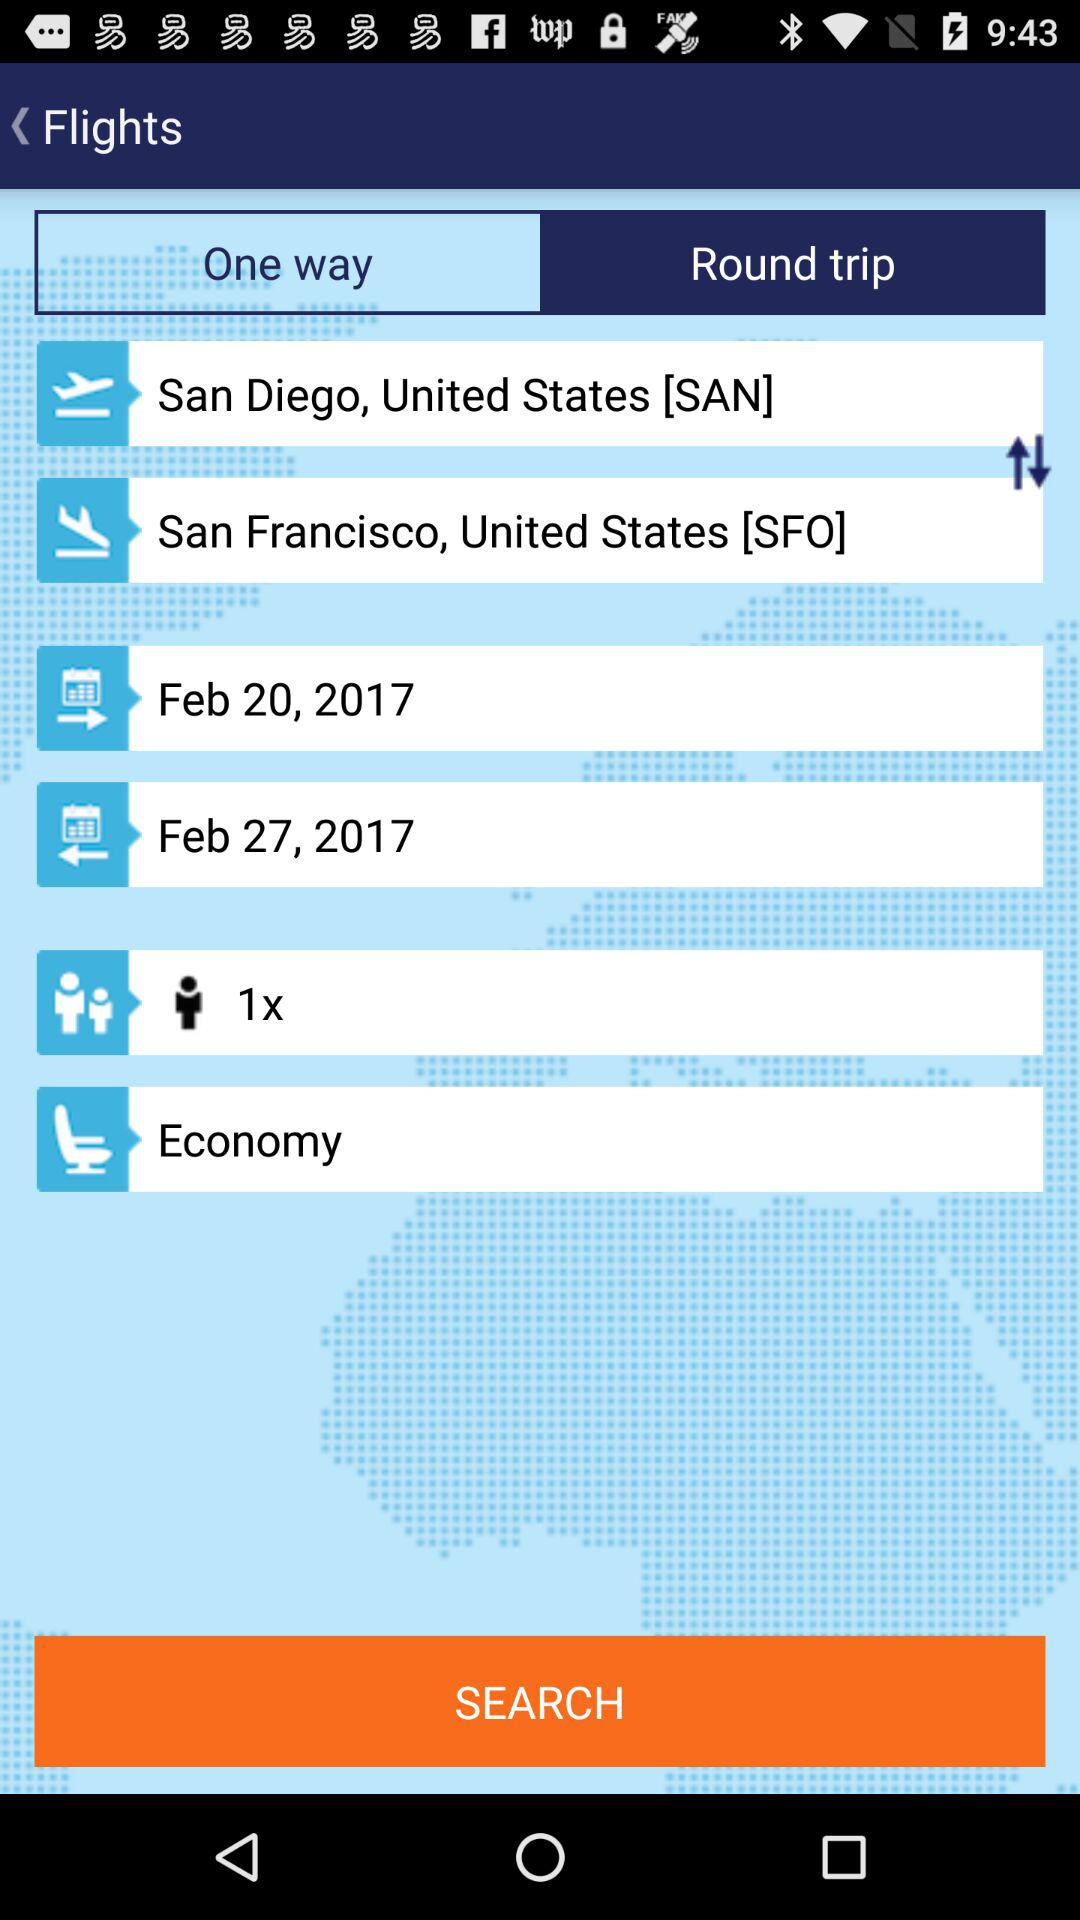How many people are traveling?
Answer the question using a single word or phrase. 1 